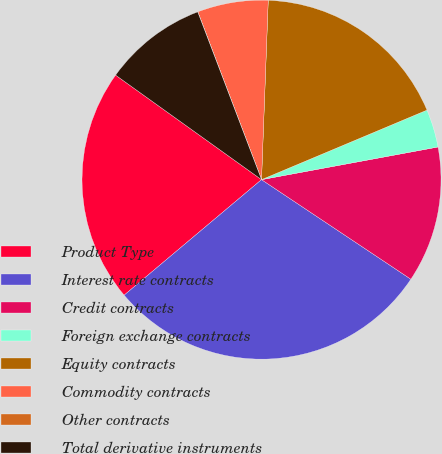<chart> <loc_0><loc_0><loc_500><loc_500><pie_chart><fcel>Product Type<fcel>Interest rate contracts<fcel>Credit contracts<fcel>Foreign exchange contracts<fcel>Equity contracts<fcel>Commodity contracts<fcel>Other contracts<fcel>Total derivative instruments<nl><fcel>21.02%<fcel>29.51%<fcel>12.27%<fcel>3.42%<fcel>18.07%<fcel>6.37%<fcel>0.01%<fcel>9.32%<nl></chart> 